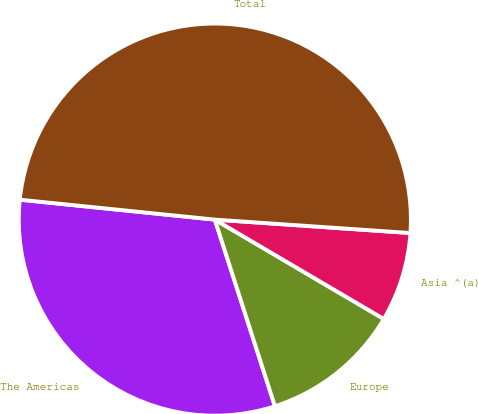Convert chart to OTSL. <chart><loc_0><loc_0><loc_500><loc_500><pie_chart><fcel>The Americas<fcel>Europe<fcel>Asia ^(a)<fcel>Total<nl><fcel>31.58%<fcel>11.58%<fcel>7.37%<fcel>49.47%<nl></chart> 